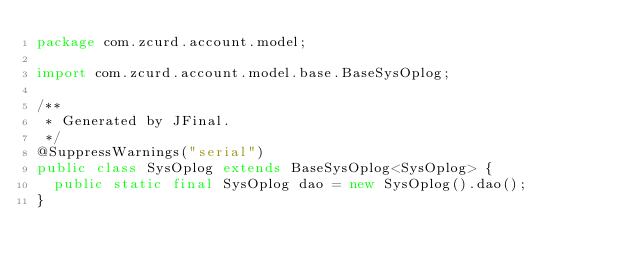Convert code to text. <code><loc_0><loc_0><loc_500><loc_500><_Java_>package com.zcurd.account.model;

import com.zcurd.account.model.base.BaseSysOplog;

/**
 * Generated by JFinal.
 */
@SuppressWarnings("serial")
public class SysOplog extends BaseSysOplog<SysOplog> {
	public static final SysOplog dao = new SysOplog().dao();
}
</code> 